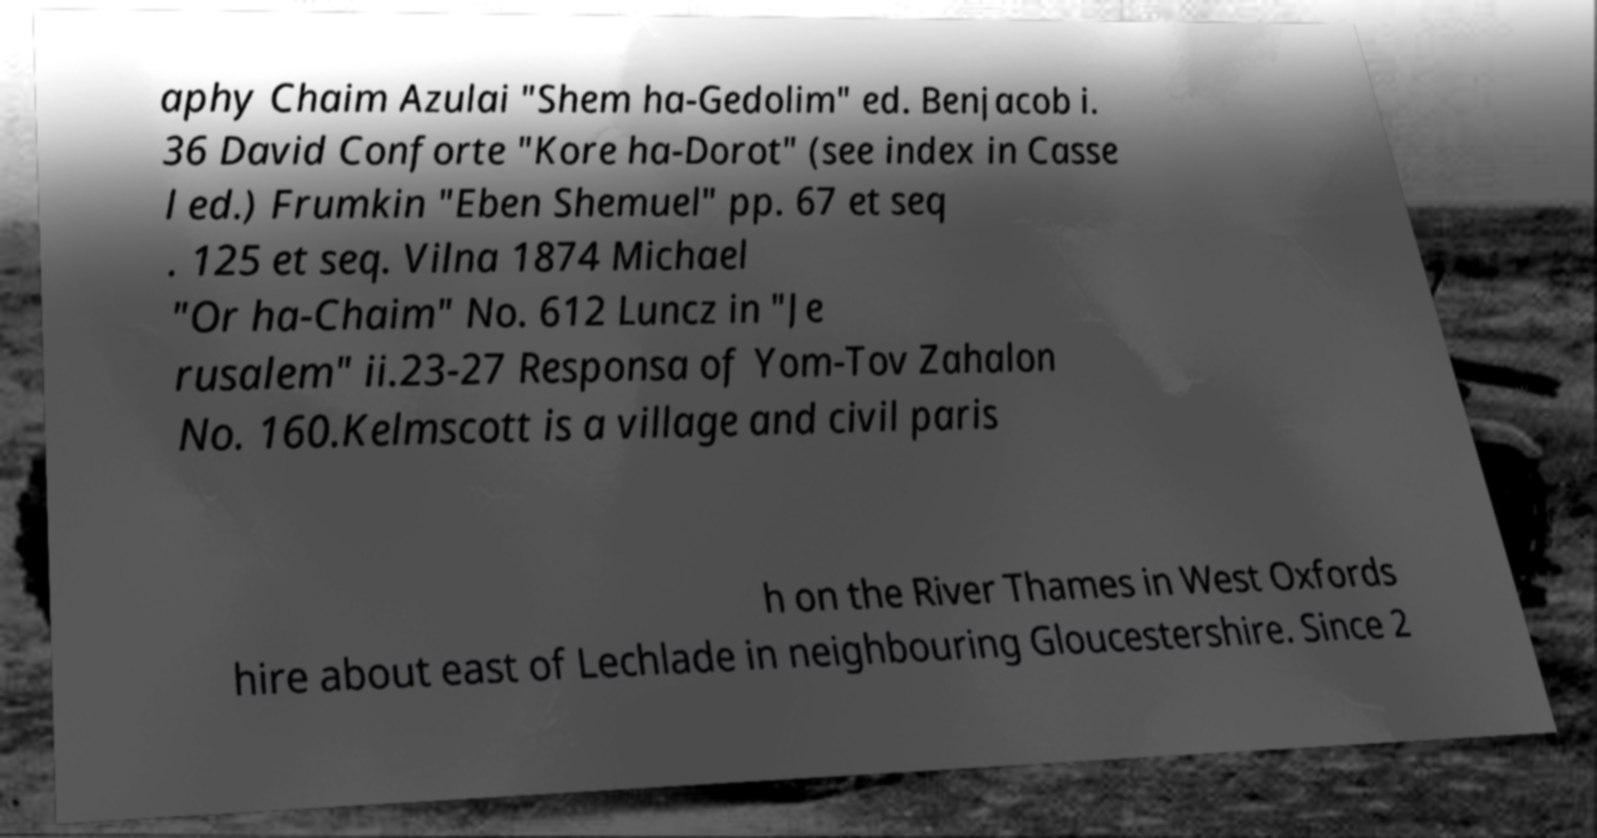Could you assist in decoding the text presented in this image and type it out clearly? aphy Chaim Azulai "Shem ha-Gedolim" ed. Benjacob i. 36 David Conforte "Kore ha-Dorot" (see index in Casse l ed.) Frumkin "Eben Shemuel" pp. 67 et seq . 125 et seq. Vilna 1874 Michael "Or ha-Chaim" No. 612 Luncz in "Je rusalem" ii.23-27 Responsa of Yom-Tov Zahalon No. 160.Kelmscott is a village and civil paris h on the River Thames in West Oxfords hire about east of Lechlade in neighbouring Gloucestershire. Since 2 